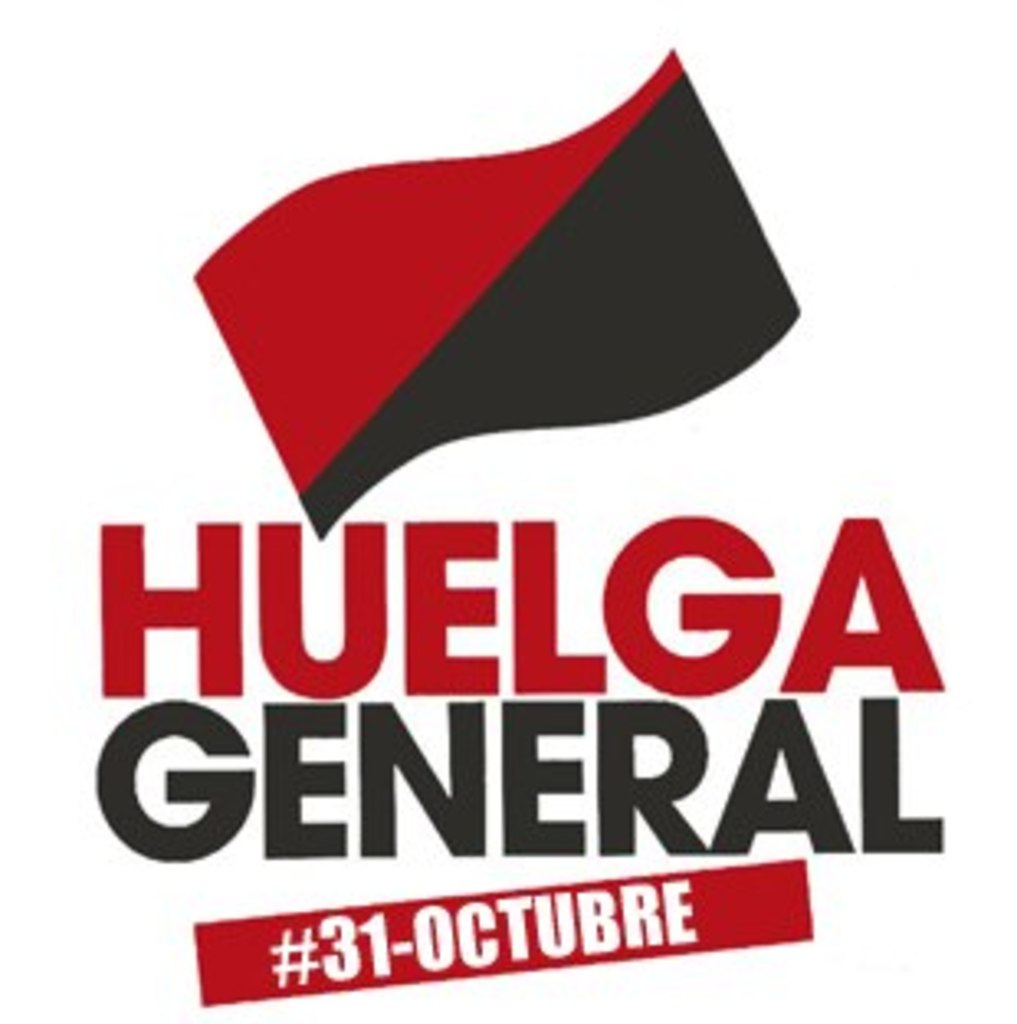What does the black and red flag symbolize in various political movements? The black and red flag is a symbol deeply entrenched in the history of anarchism and socialism. The red represents the blood or struggle of the working class against oppression, while the black symbolizes the anarchistic rejection of all oppressive structures and systems. Historically, this flag has been used by various anarchist movements around the world to signal radical unity and the fight for freedom from authoritarian rule. 